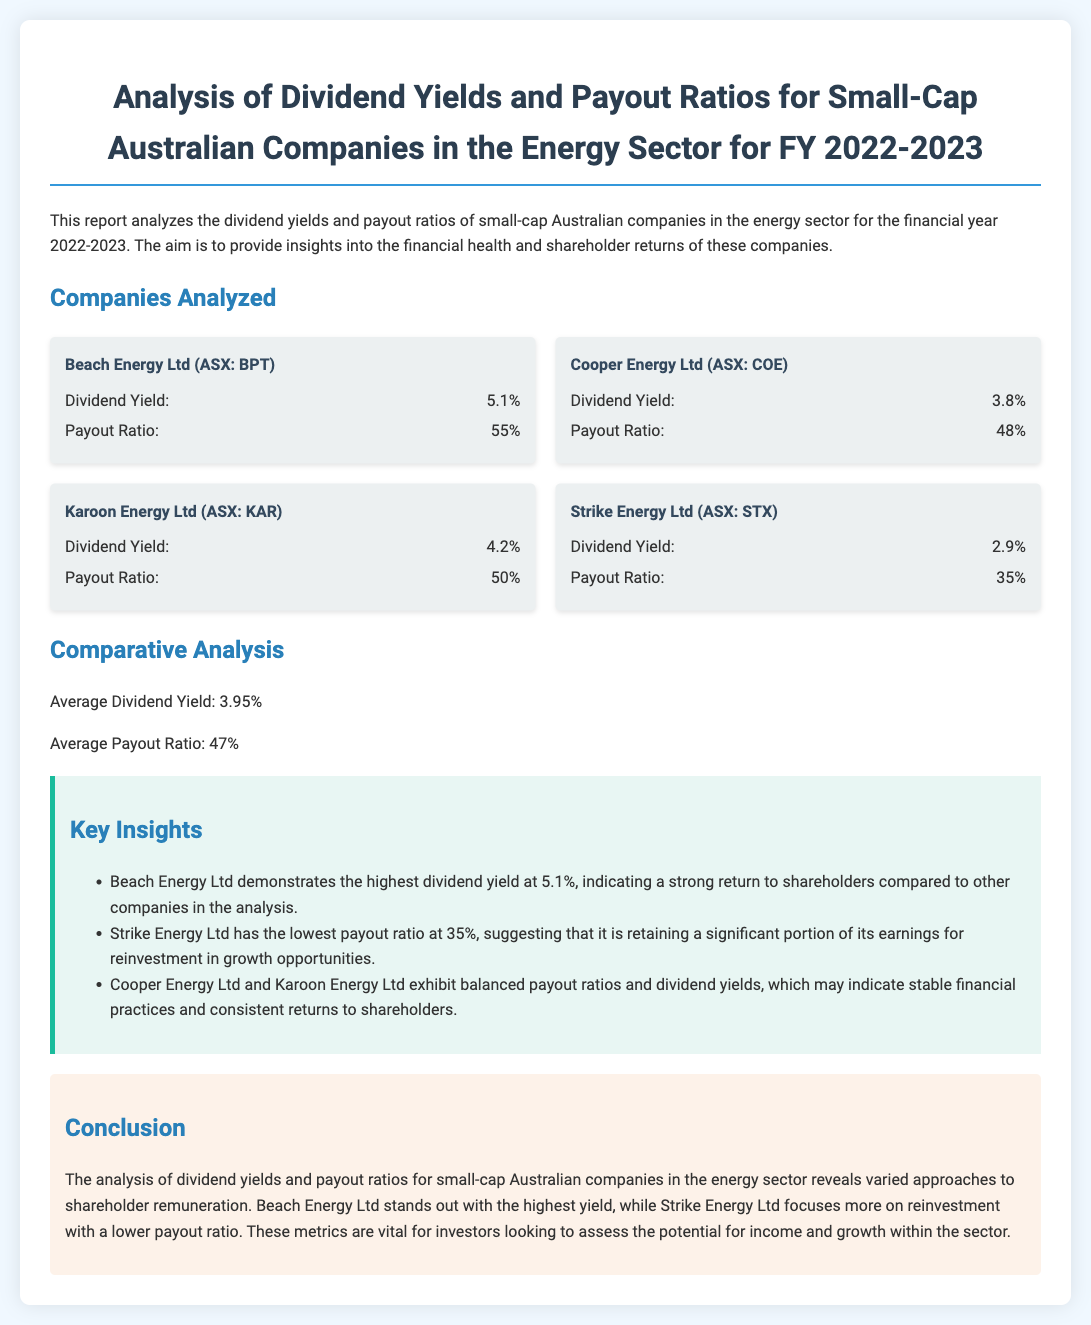What is the highest dividend yield among the companies analyzed? The highest dividend yield is provided for Beach Energy Ltd, which is stated as 5.1%.
Answer: 5.1% What is the payout ratio for Strike Energy Ltd? The payout ratio for Strike Energy Ltd is specified in the document as 35%.
Answer: 35% Which company has the lowest dividend yield? The document outlines that Strike Energy Ltd has the lowest dividend yield among the companies analyzed at 2.9%.
Answer: 2.9% What is the average dividend yield for the companies analyzed? The average dividend yield is calculated and presented as 3.95% in the comparative analysis section.
Answer: 3.95% Which company is highlighted as retaining a significant portion of its earnings for reinvestment? The document notes that Strike Energy Ltd is suggested to be retaining a significant portion of its earnings for growth, based on its low payout ratio.
Answer: Strike Energy Ltd What do Cooper Energy Ltd and Karoon Energy Ltd exhibit that may indicate stable financial practices? The document indicates that both Cooper Energy Ltd and Karoon Energy Ltd show balanced payout ratios and dividend yields, hinting at their stable financial practices.
Answer: Balanced payout ratios and dividend yields What is the average payout ratio across the companies analyzed? The average payout ratio is provided in the document as 47%.
Answer: 47% What is a key insight mentioned about Beach Energy Ltd? The document mentions that Beach Energy Ltd demonstrates the highest dividend yield, indicating a strong return to shareholders.
Answer: Highest dividend yield What aspect does the conclusion emphasize regarding the analysis of the companies? The conclusion underscores the varied approaches to shareholder remuneration, emphasizing the significance of dividend yields and payout ratios for investors.
Answer: Varied approaches to shareholder remuneration 